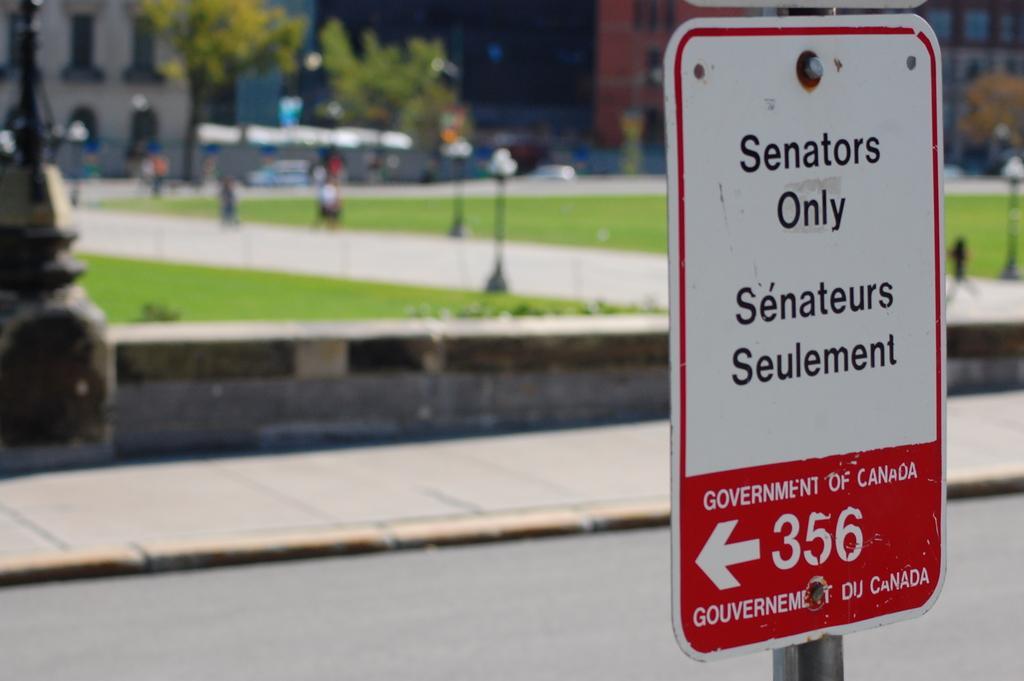Can you describe this image briefly? In the picture I can see a board which has something written on it. In the background I can see buildings, poles and some other things. The background of the image is blurred. 